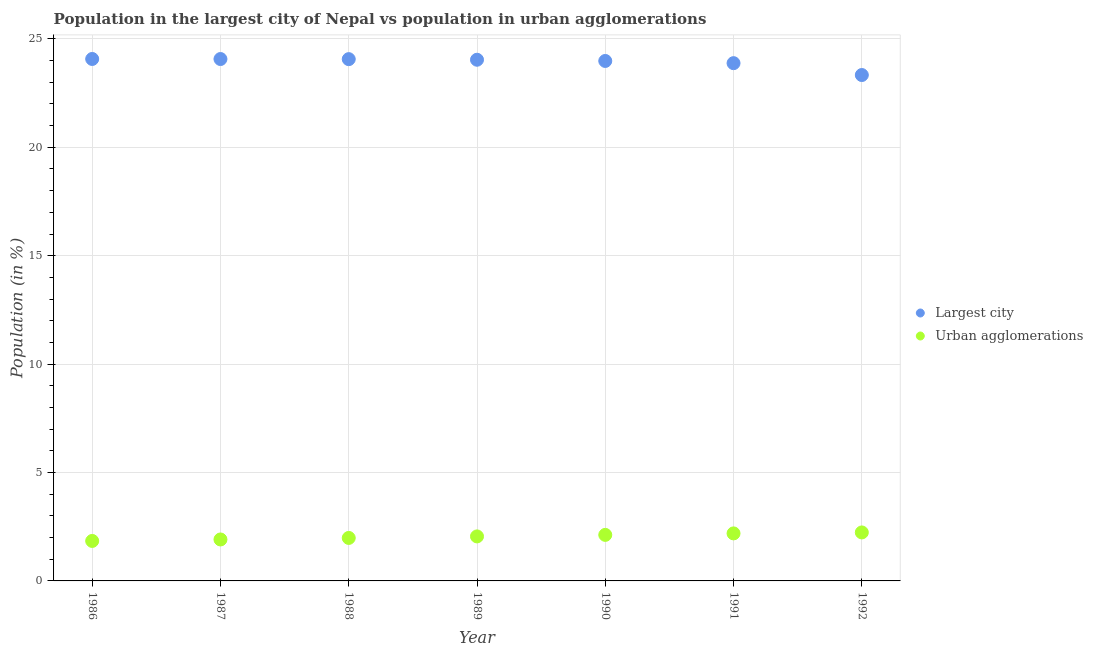What is the population in urban agglomerations in 1987?
Your answer should be compact. 1.91. Across all years, what is the maximum population in the largest city?
Provide a succinct answer. 24.07. Across all years, what is the minimum population in the largest city?
Your answer should be very brief. 23.33. In which year was the population in the largest city maximum?
Provide a short and direct response. 1986. In which year was the population in urban agglomerations minimum?
Make the answer very short. 1986. What is the total population in the largest city in the graph?
Make the answer very short. 167.45. What is the difference between the population in the largest city in 1987 and that in 1988?
Ensure brevity in your answer.  0.01. What is the difference between the population in the largest city in 1988 and the population in urban agglomerations in 1990?
Make the answer very short. 21.94. What is the average population in the largest city per year?
Keep it short and to the point. 23.92. In the year 1986, what is the difference between the population in urban agglomerations and population in the largest city?
Your answer should be very brief. -22.23. In how many years, is the population in urban agglomerations greater than 15 %?
Keep it short and to the point. 0. What is the ratio of the population in urban agglomerations in 1987 to that in 1989?
Your answer should be very brief. 0.93. Is the population in the largest city in 1986 less than that in 1988?
Provide a short and direct response. No. What is the difference between the highest and the second highest population in the largest city?
Provide a short and direct response. 0. What is the difference between the highest and the lowest population in the largest city?
Offer a terse response. 0.74. Are the values on the major ticks of Y-axis written in scientific E-notation?
Your response must be concise. No. Does the graph contain any zero values?
Offer a very short reply. No. How are the legend labels stacked?
Your answer should be compact. Vertical. What is the title of the graph?
Ensure brevity in your answer.  Population in the largest city of Nepal vs population in urban agglomerations. Does "Resident" appear as one of the legend labels in the graph?
Your answer should be very brief. No. What is the label or title of the Y-axis?
Keep it short and to the point. Population (in %). What is the Population (in %) in Largest city in 1986?
Provide a succinct answer. 24.07. What is the Population (in %) in Urban agglomerations in 1986?
Provide a short and direct response. 1.84. What is the Population (in %) in Largest city in 1987?
Keep it short and to the point. 24.07. What is the Population (in %) in Urban agglomerations in 1987?
Offer a terse response. 1.91. What is the Population (in %) of Largest city in 1988?
Make the answer very short. 24.07. What is the Population (in %) in Urban agglomerations in 1988?
Keep it short and to the point. 1.98. What is the Population (in %) in Largest city in 1989?
Keep it short and to the point. 24.04. What is the Population (in %) of Urban agglomerations in 1989?
Keep it short and to the point. 2.05. What is the Population (in %) of Largest city in 1990?
Your response must be concise. 23.98. What is the Population (in %) of Urban agglomerations in 1990?
Your answer should be very brief. 2.12. What is the Population (in %) in Largest city in 1991?
Ensure brevity in your answer.  23.88. What is the Population (in %) of Urban agglomerations in 1991?
Ensure brevity in your answer.  2.19. What is the Population (in %) in Largest city in 1992?
Make the answer very short. 23.33. What is the Population (in %) of Urban agglomerations in 1992?
Your answer should be compact. 2.24. Across all years, what is the maximum Population (in %) of Largest city?
Give a very brief answer. 24.07. Across all years, what is the maximum Population (in %) of Urban agglomerations?
Offer a very short reply. 2.24. Across all years, what is the minimum Population (in %) in Largest city?
Provide a succinct answer. 23.33. Across all years, what is the minimum Population (in %) of Urban agglomerations?
Provide a succinct answer. 1.84. What is the total Population (in %) of Largest city in the graph?
Provide a succinct answer. 167.45. What is the total Population (in %) of Urban agglomerations in the graph?
Give a very brief answer. 14.34. What is the difference between the Population (in %) in Largest city in 1986 and that in 1987?
Offer a very short reply. 0. What is the difference between the Population (in %) of Urban agglomerations in 1986 and that in 1987?
Your response must be concise. -0.07. What is the difference between the Population (in %) in Largest city in 1986 and that in 1988?
Ensure brevity in your answer.  0.01. What is the difference between the Population (in %) of Urban agglomerations in 1986 and that in 1988?
Give a very brief answer. -0.14. What is the difference between the Population (in %) in Largest city in 1986 and that in 1989?
Give a very brief answer. 0.04. What is the difference between the Population (in %) of Urban agglomerations in 1986 and that in 1989?
Your answer should be compact. -0.21. What is the difference between the Population (in %) of Largest city in 1986 and that in 1990?
Provide a short and direct response. 0.09. What is the difference between the Population (in %) of Urban agglomerations in 1986 and that in 1990?
Provide a short and direct response. -0.28. What is the difference between the Population (in %) of Largest city in 1986 and that in 1991?
Provide a succinct answer. 0.19. What is the difference between the Population (in %) in Urban agglomerations in 1986 and that in 1991?
Ensure brevity in your answer.  -0.35. What is the difference between the Population (in %) in Largest city in 1986 and that in 1992?
Offer a terse response. 0.74. What is the difference between the Population (in %) of Urban agglomerations in 1986 and that in 1992?
Your answer should be very brief. -0.39. What is the difference between the Population (in %) in Largest city in 1987 and that in 1988?
Offer a very short reply. 0.01. What is the difference between the Population (in %) of Urban agglomerations in 1987 and that in 1988?
Offer a terse response. -0.07. What is the difference between the Population (in %) in Largest city in 1987 and that in 1989?
Your response must be concise. 0.03. What is the difference between the Population (in %) in Urban agglomerations in 1987 and that in 1989?
Make the answer very short. -0.14. What is the difference between the Population (in %) of Largest city in 1987 and that in 1990?
Your response must be concise. 0.09. What is the difference between the Population (in %) in Urban agglomerations in 1987 and that in 1990?
Give a very brief answer. -0.21. What is the difference between the Population (in %) in Largest city in 1987 and that in 1991?
Keep it short and to the point. 0.19. What is the difference between the Population (in %) in Urban agglomerations in 1987 and that in 1991?
Your response must be concise. -0.28. What is the difference between the Population (in %) of Largest city in 1987 and that in 1992?
Your answer should be very brief. 0.74. What is the difference between the Population (in %) in Urban agglomerations in 1987 and that in 1992?
Provide a succinct answer. -0.32. What is the difference between the Population (in %) of Largest city in 1988 and that in 1989?
Your answer should be very brief. 0.03. What is the difference between the Population (in %) in Urban agglomerations in 1988 and that in 1989?
Offer a terse response. -0.07. What is the difference between the Population (in %) of Largest city in 1988 and that in 1990?
Provide a succinct answer. 0.08. What is the difference between the Population (in %) in Urban agglomerations in 1988 and that in 1990?
Your answer should be very brief. -0.14. What is the difference between the Population (in %) of Largest city in 1988 and that in 1991?
Make the answer very short. 0.19. What is the difference between the Population (in %) in Urban agglomerations in 1988 and that in 1991?
Make the answer very short. -0.21. What is the difference between the Population (in %) of Largest city in 1988 and that in 1992?
Provide a short and direct response. 0.73. What is the difference between the Population (in %) in Urban agglomerations in 1988 and that in 1992?
Your response must be concise. -0.25. What is the difference between the Population (in %) in Largest city in 1989 and that in 1990?
Provide a succinct answer. 0.06. What is the difference between the Population (in %) of Urban agglomerations in 1989 and that in 1990?
Keep it short and to the point. -0.07. What is the difference between the Population (in %) in Largest city in 1989 and that in 1991?
Provide a succinct answer. 0.16. What is the difference between the Population (in %) in Urban agglomerations in 1989 and that in 1991?
Provide a short and direct response. -0.14. What is the difference between the Population (in %) in Largest city in 1989 and that in 1992?
Ensure brevity in your answer.  0.71. What is the difference between the Population (in %) in Urban agglomerations in 1989 and that in 1992?
Provide a succinct answer. -0.18. What is the difference between the Population (in %) in Largest city in 1990 and that in 1991?
Give a very brief answer. 0.1. What is the difference between the Population (in %) in Urban agglomerations in 1990 and that in 1991?
Offer a terse response. -0.07. What is the difference between the Population (in %) in Largest city in 1990 and that in 1992?
Offer a terse response. 0.65. What is the difference between the Population (in %) of Urban agglomerations in 1990 and that in 1992?
Your answer should be compact. -0.11. What is the difference between the Population (in %) of Largest city in 1991 and that in 1992?
Your answer should be compact. 0.55. What is the difference between the Population (in %) in Urban agglomerations in 1991 and that in 1992?
Provide a short and direct response. -0.04. What is the difference between the Population (in %) in Largest city in 1986 and the Population (in %) in Urban agglomerations in 1987?
Your response must be concise. 22.16. What is the difference between the Population (in %) of Largest city in 1986 and the Population (in %) of Urban agglomerations in 1988?
Offer a terse response. 22.09. What is the difference between the Population (in %) in Largest city in 1986 and the Population (in %) in Urban agglomerations in 1989?
Give a very brief answer. 22.02. What is the difference between the Population (in %) of Largest city in 1986 and the Population (in %) of Urban agglomerations in 1990?
Give a very brief answer. 21.95. What is the difference between the Population (in %) of Largest city in 1986 and the Population (in %) of Urban agglomerations in 1991?
Your answer should be very brief. 21.88. What is the difference between the Population (in %) in Largest city in 1986 and the Population (in %) in Urban agglomerations in 1992?
Your response must be concise. 21.84. What is the difference between the Population (in %) in Largest city in 1987 and the Population (in %) in Urban agglomerations in 1988?
Keep it short and to the point. 22.09. What is the difference between the Population (in %) of Largest city in 1987 and the Population (in %) of Urban agglomerations in 1989?
Your response must be concise. 22.02. What is the difference between the Population (in %) of Largest city in 1987 and the Population (in %) of Urban agglomerations in 1990?
Offer a terse response. 21.95. What is the difference between the Population (in %) of Largest city in 1987 and the Population (in %) of Urban agglomerations in 1991?
Provide a succinct answer. 21.88. What is the difference between the Population (in %) of Largest city in 1987 and the Population (in %) of Urban agglomerations in 1992?
Give a very brief answer. 21.84. What is the difference between the Population (in %) in Largest city in 1988 and the Population (in %) in Urban agglomerations in 1989?
Offer a very short reply. 22.01. What is the difference between the Population (in %) of Largest city in 1988 and the Population (in %) of Urban agglomerations in 1990?
Offer a terse response. 21.94. What is the difference between the Population (in %) in Largest city in 1988 and the Population (in %) in Urban agglomerations in 1991?
Ensure brevity in your answer.  21.87. What is the difference between the Population (in %) in Largest city in 1988 and the Population (in %) in Urban agglomerations in 1992?
Your response must be concise. 21.83. What is the difference between the Population (in %) of Largest city in 1989 and the Population (in %) of Urban agglomerations in 1990?
Give a very brief answer. 21.92. What is the difference between the Population (in %) in Largest city in 1989 and the Population (in %) in Urban agglomerations in 1991?
Your answer should be very brief. 21.85. What is the difference between the Population (in %) in Largest city in 1989 and the Population (in %) in Urban agglomerations in 1992?
Offer a very short reply. 21.8. What is the difference between the Population (in %) of Largest city in 1990 and the Population (in %) of Urban agglomerations in 1991?
Your response must be concise. 21.79. What is the difference between the Population (in %) in Largest city in 1990 and the Population (in %) in Urban agglomerations in 1992?
Your answer should be very brief. 21.75. What is the difference between the Population (in %) in Largest city in 1991 and the Population (in %) in Urban agglomerations in 1992?
Offer a terse response. 21.64. What is the average Population (in %) of Largest city per year?
Offer a terse response. 23.92. What is the average Population (in %) of Urban agglomerations per year?
Make the answer very short. 2.05. In the year 1986, what is the difference between the Population (in %) of Largest city and Population (in %) of Urban agglomerations?
Offer a very short reply. 22.23. In the year 1987, what is the difference between the Population (in %) of Largest city and Population (in %) of Urban agglomerations?
Keep it short and to the point. 22.16. In the year 1988, what is the difference between the Population (in %) of Largest city and Population (in %) of Urban agglomerations?
Ensure brevity in your answer.  22.08. In the year 1989, what is the difference between the Population (in %) in Largest city and Population (in %) in Urban agglomerations?
Provide a short and direct response. 21.99. In the year 1990, what is the difference between the Population (in %) of Largest city and Population (in %) of Urban agglomerations?
Provide a succinct answer. 21.86. In the year 1991, what is the difference between the Population (in %) in Largest city and Population (in %) in Urban agglomerations?
Offer a terse response. 21.69. In the year 1992, what is the difference between the Population (in %) of Largest city and Population (in %) of Urban agglomerations?
Keep it short and to the point. 21.1. What is the ratio of the Population (in %) of Largest city in 1986 to that in 1987?
Make the answer very short. 1. What is the ratio of the Population (in %) in Urban agglomerations in 1986 to that in 1987?
Keep it short and to the point. 0.96. What is the ratio of the Population (in %) of Largest city in 1986 to that in 1988?
Make the answer very short. 1. What is the ratio of the Population (in %) in Urban agglomerations in 1986 to that in 1988?
Your answer should be very brief. 0.93. What is the ratio of the Population (in %) in Urban agglomerations in 1986 to that in 1989?
Give a very brief answer. 0.9. What is the ratio of the Population (in %) of Urban agglomerations in 1986 to that in 1990?
Your answer should be very brief. 0.87. What is the ratio of the Population (in %) in Urban agglomerations in 1986 to that in 1991?
Your answer should be compact. 0.84. What is the ratio of the Population (in %) of Largest city in 1986 to that in 1992?
Your answer should be very brief. 1.03. What is the ratio of the Population (in %) in Urban agglomerations in 1986 to that in 1992?
Your answer should be very brief. 0.82. What is the ratio of the Population (in %) of Largest city in 1987 to that in 1988?
Provide a succinct answer. 1. What is the ratio of the Population (in %) of Urban agglomerations in 1987 to that in 1988?
Make the answer very short. 0.96. What is the ratio of the Population (in %) of Largest city in 1987 to that in 1989?
Ensure brevity in your answer.  1. What is the ratio of the Population (in %) in Urban agglomerations in 1987 to that in 1989?
Ensure brevity in your answer.  0.93. What is the ratio of the Population (in %) in Largest city in 1987 to that in 1990?
Ensure brevity in your answer.  1. What is the ratio of the Population (in %) in Urban agglomerations in 1987 to that in 1990?
Your response must be concise. 0.9. What is the ratio of the Population (in %) of Urban agglomerations in 1987 to that in 1991?
Offer a terse response. 0.87. What is the ratio of the Population (in %) of Largest city in 1987 to that in 1992?
Offer a very short reply. 1.03. What is the ratio of the Population (in %) of Urban agglomerations in 1987 to that in 1992?
Offer a terse response. 0.85. What is the ratio of the Population (in %) of Largest city in 1988 to that in 1989?
Provide a succinct answer. 1. What is the ratio of the Population (in %) in Urban agglomerations in 1988 to that in 1989?
Provide a succinct answer. 0.97. What is the ratio of the Population (in %) in Largest city in 1988 to that in 1990?
Your response must be concise. 1. What is the ratio of the Population (in %) in Urban agglomerations in 1988 to that in 1990?
Your response must be concise. 0.93. What is the ratio of the Population (in %) of Largest city in 1988 to that in 1991?
Provide a short and direct response. 1.01. What is the ratio of the Population (in %) of Urban agglomerations in 1988 to that in 1991?
Provide a succinct answer. 0.9. What is the ratio of the Population (in %) in Largest city in 1988 to that in 1992?
Offer a very short reply. 1.03. What is the ratio of the Population (in %) in Urban agglomerations in 1988 to that in 1992?
Your answer should be very brief. 0.89. What is the ratio of the Population (in %) in Largest city in 1989 to that in 1990?
Provide a succinct answer. 1. What is the ratio of the Population (in %) of Urban agglomerations in 1989 to that in 1990?
Offer a terse response. 0.97. What is the ratio of the Population (in %) in Largest city in 1989 to that in 1991?
Ensure brevity in your answer.  1.01. What is the ratio of the Population (in %) of Urban agglomerations in 1989 to that in 1991?
Give a very brief answer. 0.94. What is the ratio of the Population (in %) in Largest city in 1989 to that in 1992?
Make the answer very short. 1.03. What is the ratio of the Population (in %) of Urban agglomerations in 1989 to that in 1992?
Give a very brief answer. 0.92. What is the ratio of the Population (in %) of Urban agglomerations in 1990 to that in 1991?
Offer a terse response. 0.97. What is the ratio of the Population (in %) of Largest city in 1990 to that in 1992?
Give a very brief answer. 1.03. What is the ratio of the Population (in %) of Urban agglomerations in 1990 to that in 1992?
Your response must be concise. 0.95. What is the ratio of the Population (in %) of Largest city in 1991 to that in 1992?
Ensure brevity in your answer.  1.02. What is the ratio of the Population (in %) of Urban agglomerations in 1991 to that in 1992?
Provide a succinct answer. 0.98. What is the difference between the highest and the second highest Population (in %) in Largest city?
Make the answer very short. 0. What is the difference between the highest and the second highest Population (in %) of Urban agglomerations?
Offer a terse response. 0.04. What is the difference between the highest and the lowest Population (in %) of Largest city?
Provide a succinct answer. 0.74. What is the difference between the highest and the lowest Population (in %) of Urban agglomerations?
Your answer should be compact. 0.39. 